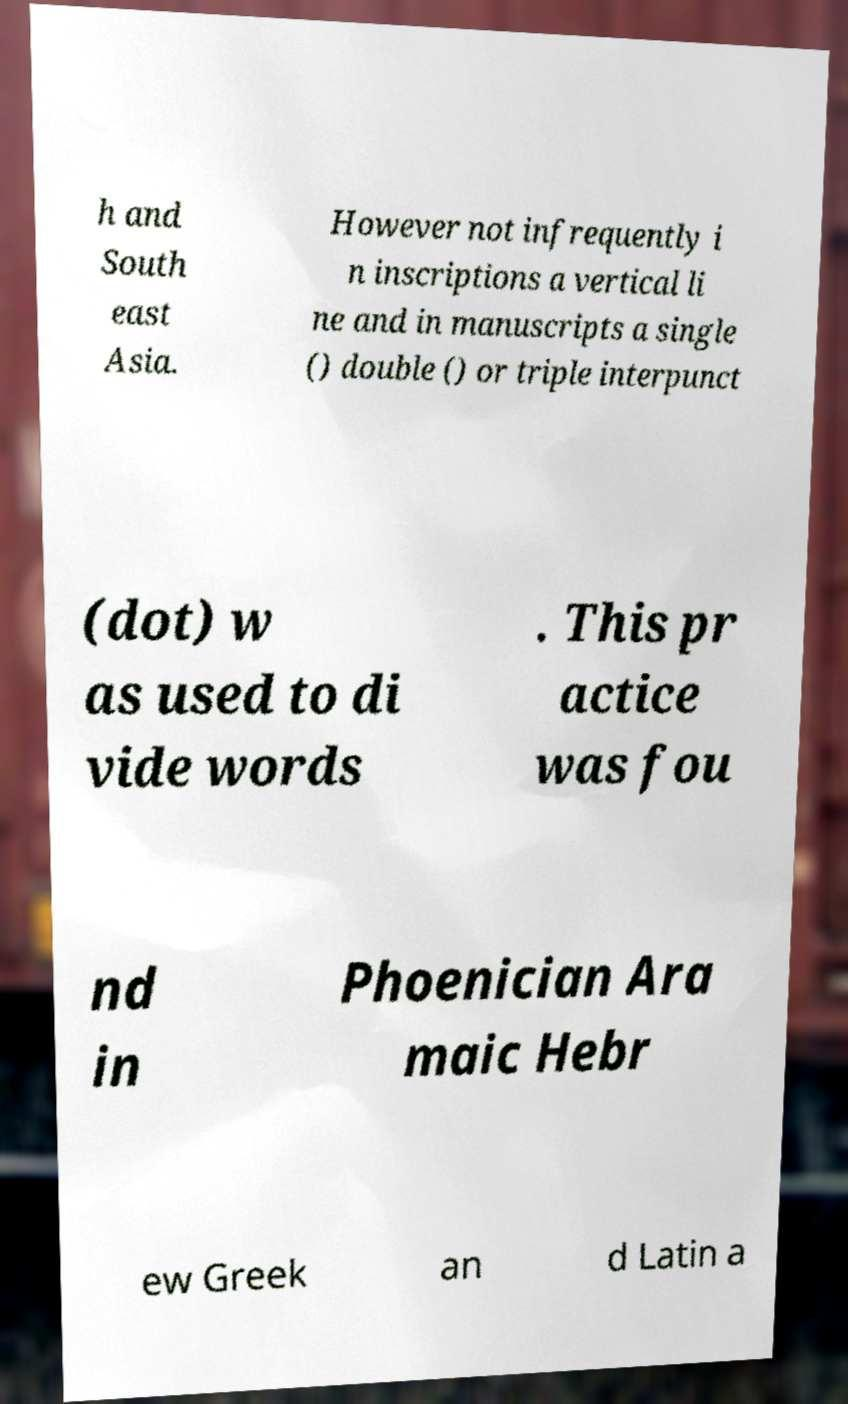I need the written content from this picture converted into text. Can you do that? h and South east Asia. However not infrequently i n inscriptions a vertical li ne and in manuscripts a single () double () or triple interpunct (dot) w as used to di vide words . This pr actice was fou nd in Phoenician Ara maic Hebr ew Greek an d Latin a 